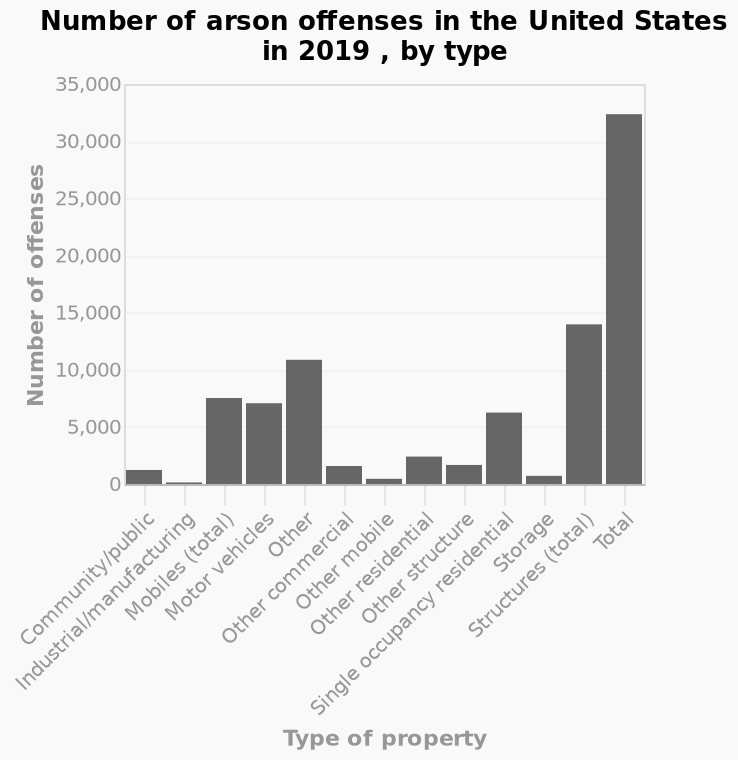<image>
What does the x-axis represent in the bar chart?  The x-axis represents the different types of properties affected by arson offenses in the United States in 2019. What does the bar chart depict in terms of the United States and arson offenses in 2019? The bar chart provides a visual representation of the number of arson offenses committed in the United States in 2019, categorized by different types of properties. How is the data represented in the chart? The data is represented through bars, where each bar corresponds to a type of property, and its height represents the number of arson offenses for that particular property type. 